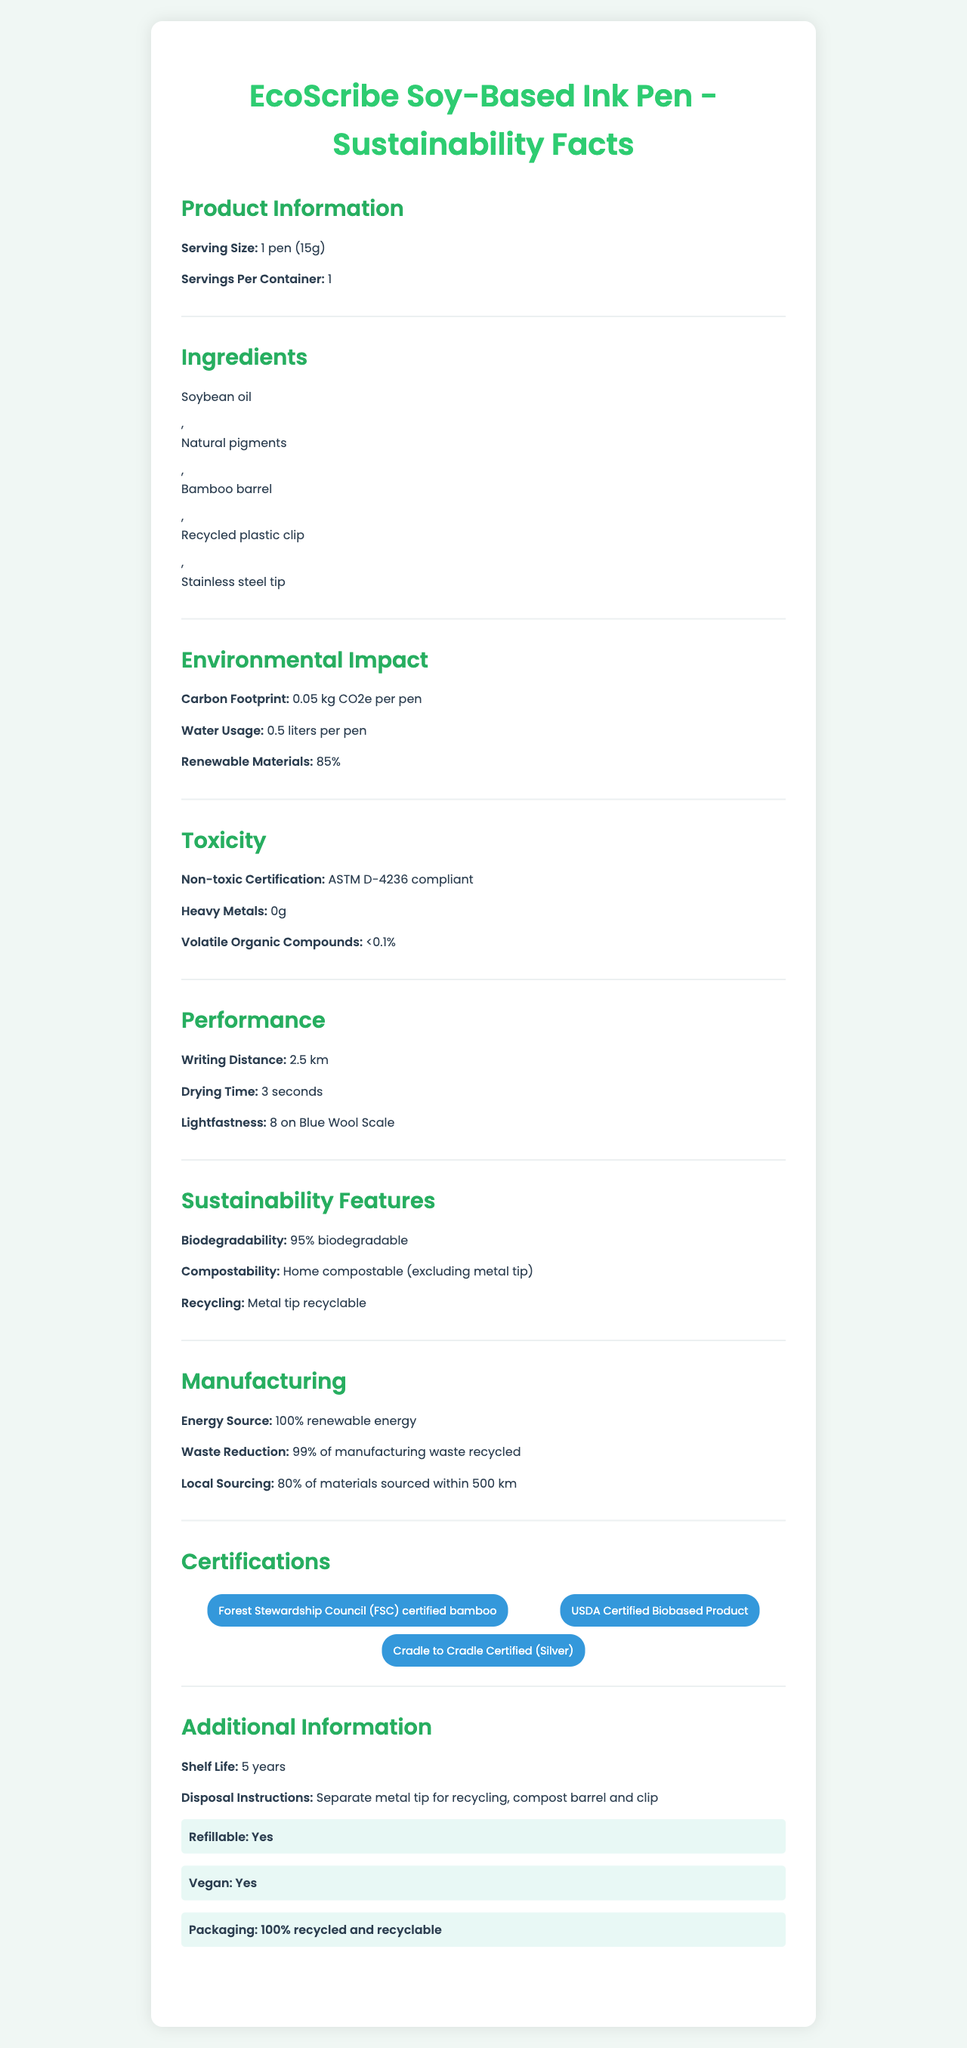What is the carbon footprint of each EcoScribe Soy-Based Ink Pen? The document explicitly states the carbon footprint under the Environmental Impact section as "0.05 kg CO2e per pen".
Answer: 0.05 kg CO2e per pen What are the primary ingredients used in the EcoScribe Soy-Based Ink Pen? The Ingredients section lists these specific components.
Answer: Soybean oil, Natural pigments, Bamboo barrel, Recycled plastic clip, Stainless steel tip What percentage of the materials used in the EcoScribe Soy-Based Ink Pen is renewable? According to the Environmental Impact section, renewable materials constitute 85%.
Answer: 85% What certification indicates the pen meets non-toxic standards? The Toxcity section mentions non-toxic certification as "ASTM D-4236 compliant".
Answer: ASTM D-4236 Which component of the EcoScribe Soy-Based Ink Pen is not compostable? The Sustainability Features section indicates that the pen is home compostable excluding the metal tip.
Answer: Stainless steel tip How long does the EcoScribe Soy-Based Ink Pen last when stored properly? The Additional Information section notes the shelf life as "5 years".
Answer: 5 years What is the drying time of the ink in the EcoScribe Soy-Based Ink Pen? A. 1 second B. 3 seconds C. 5 seconds D. 10 seconds The Performance section mentions that the drying time is 3 seconds.
Answer: B. 3 seconds Which of the following certifications does the pen have? I. USDA Certified Biobased Product II. LEED Certified III. Cradle to Cradle Certified (Silver) The Certifications section lists USDA Certified Biobased Product and Cradle to Cradle Certified (Silver) but does not mention LEED.
Answer: I and III Does the EcoScribe Soy-Based Ink Pen reduce carbon footprint? The Environmental Impact section lists a low carbon footprint of 0.05 kg CO2e per pen as part of its sustainability features.
Answer: Yes Summarize the main idea of the document. This explanation highlights the various sections of the document, covering product information, environmental impact, toxicity, performance, sustainability features, manufacturing, certifications, shelf life, and additional information regarding disposal and refillability.
Answer: The document details the sustainability features, ingredients, performance, certifications, and environmental impact of the EcoScribe Soy-Based Ink Pen, emphasizing its non-toxic ingredients, use of renewable materials, and reduced carbon footprint. Where is the ink for the EcoScribe pen manufactured? The document does not provide any information about the specific location of the ink manufacturing.
Answer: Cannot be determined 